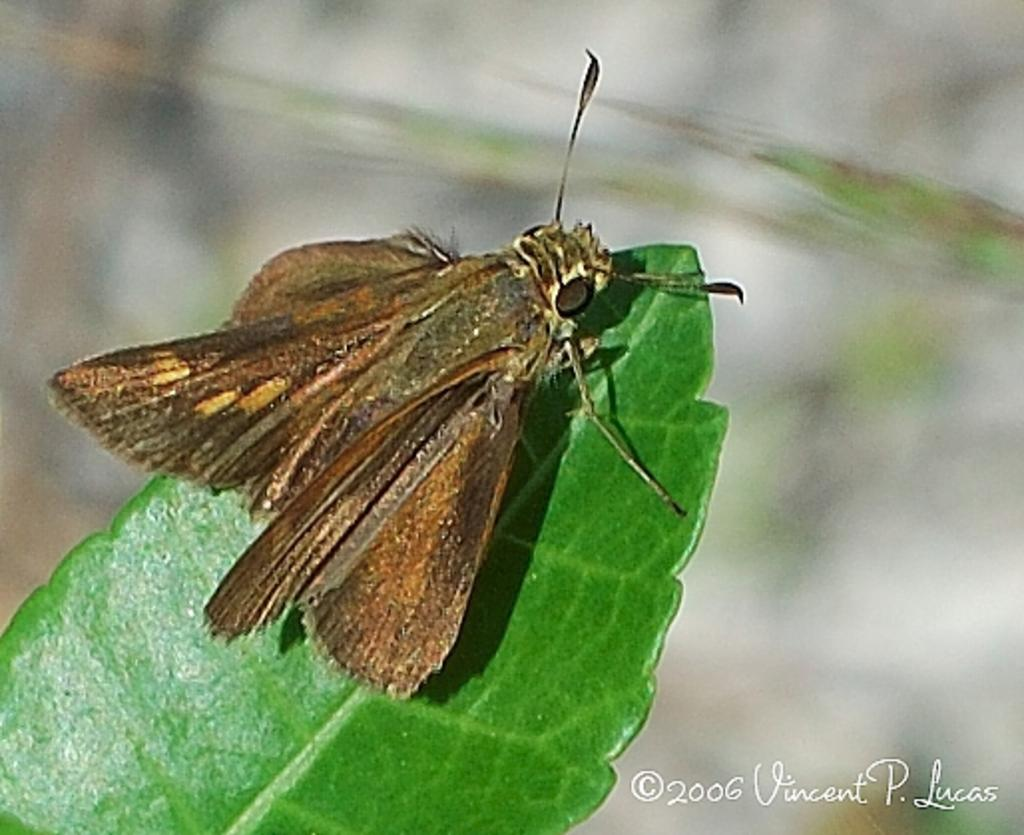What is present on the green leaf in the image? There is an insect on a green leaf in the image. How would you describe the background of the image? The background of the image is blurry. Where can text be found in the image? Text is located at the bottom right of the image. How does the turkey react to the sneeze in the image? There is no turkey or sneeze present in the image. What type of plough is being used in the image? There is no plough present in the image. 